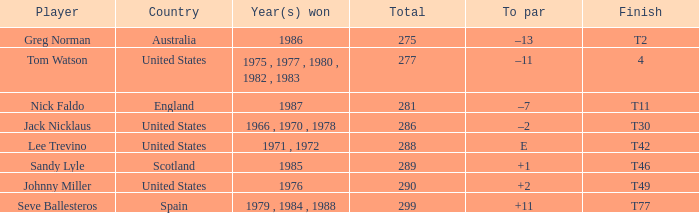Which nation achieved a conclusion of t42? United States. 